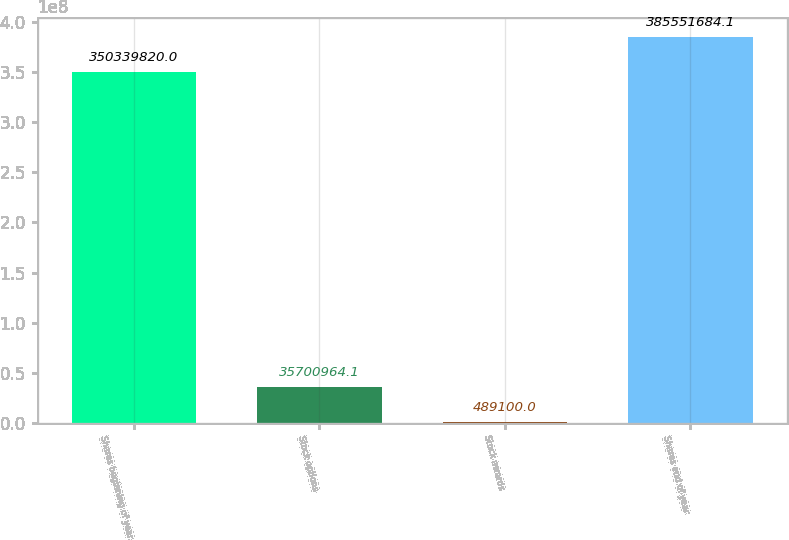Convert chart to OTSL. <chart><loc_0><loc_0><loc_500><loc_500><bar_chart><fcel>Shares beginning of year<fcel>Stock options<fcel>Stock awards<fcel>Shares end of year<nl><fcel>3.5034e+08<fcel>3.5701e+07<fcel>489100<fcel>3.85552e+08<nl></chart> 